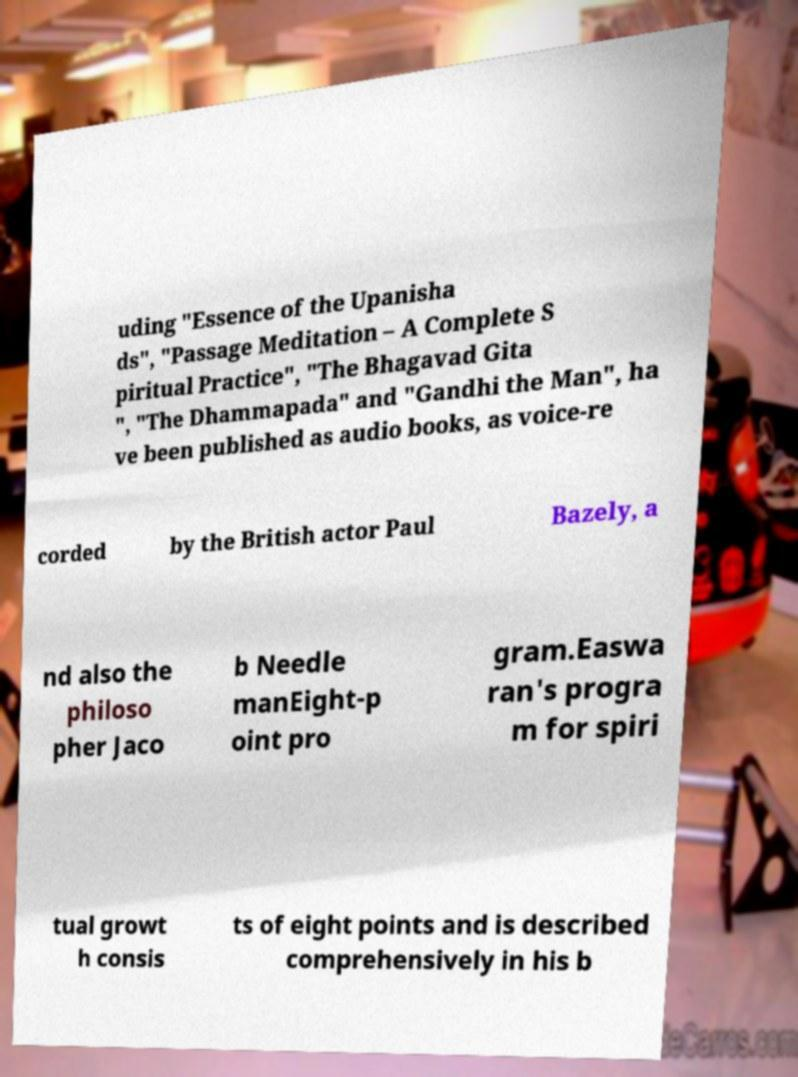Please identify and transcribe the text found in this image. uding "Essence of the Upanisha ds", "Passage Meditation – A Complete S piritual Practice", "The Bhagavad Gita ", "The Dhammapada" and "Gandhi the Man", ha ve been published as audio books, as voice-re corded by the British actor Paul Bazely, a nd also the philoso pher Jaco b Needle manEight-p oint pro gram.Easwa ran's progra m for spiri tual growt h consis ts of eight points and is described comprehensively in his b 